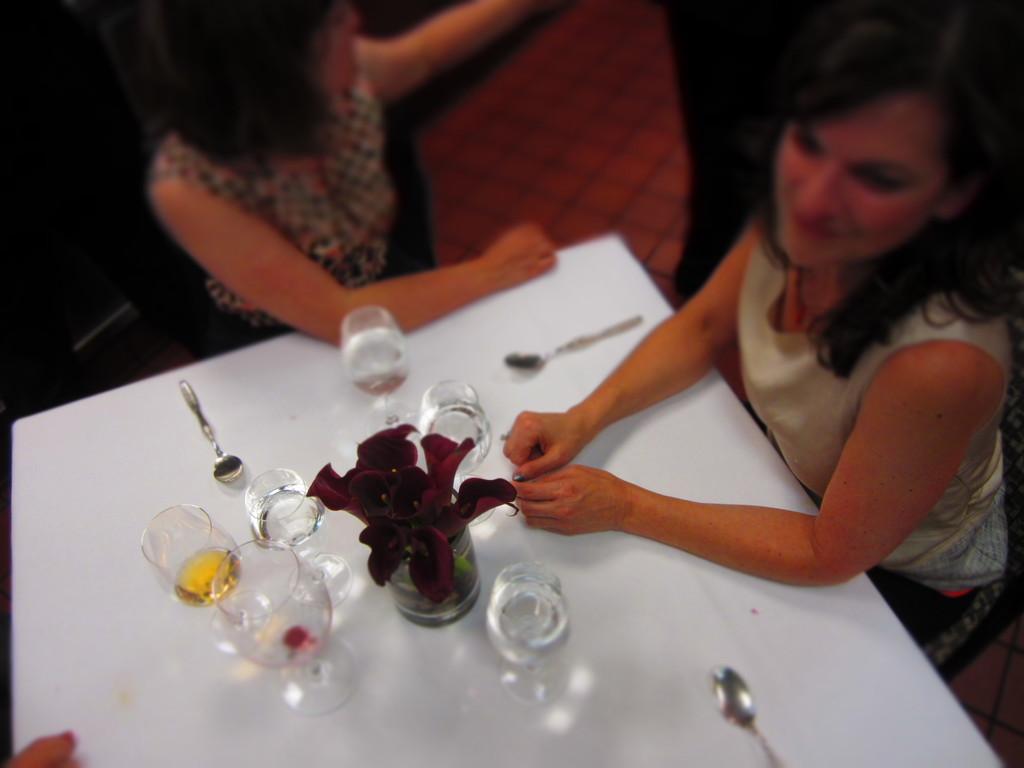Can you describe this image briefly? There are two women's sitting on a chair, right woman is smiling. Here it's a table, on the table we can see three spoons. Five glasses containing water and one of the glass contains a wine. Here it's a flower. Bottom-left we can see a finger of a person. 